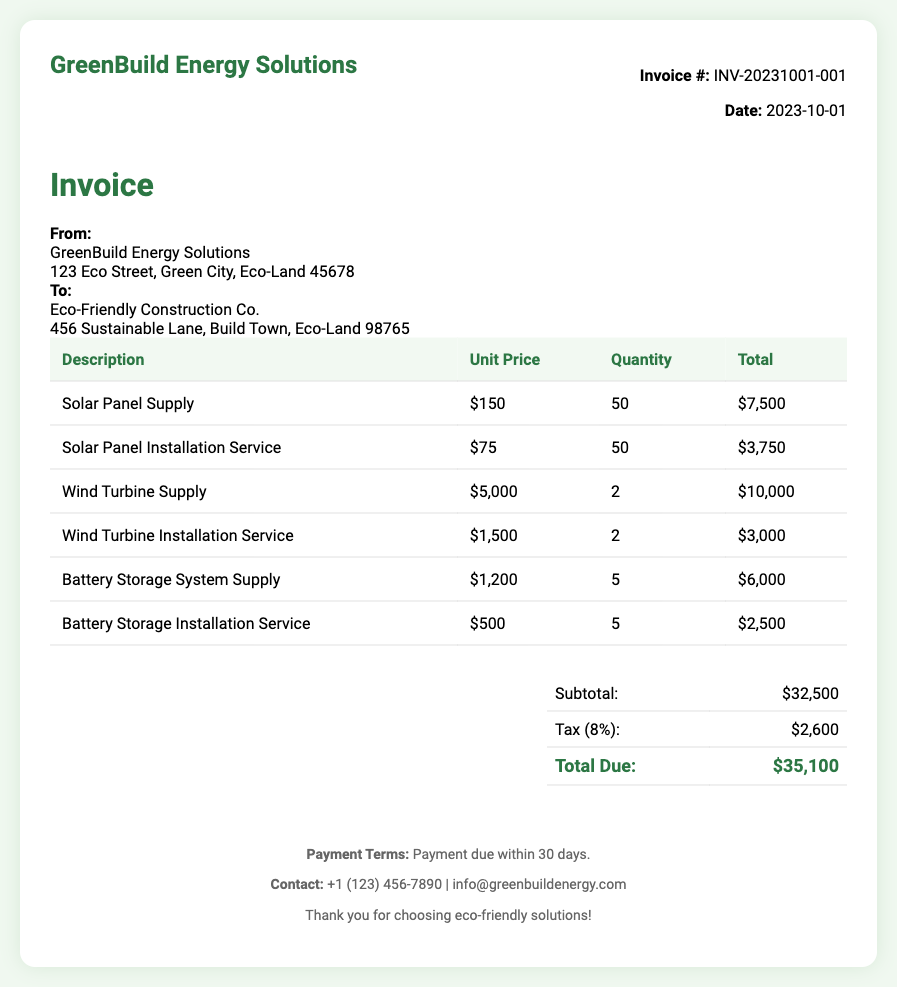What is the invoice number? The invoice number is specified in the document under invoice details.
Answer: INV-20231001-001 What is the date of the invoice? The date is provided clearly in the document.
Answer: 2023-10-01 Who is the recipient of the invoice? The recipient's name and address are mentioned in the "To:" section of the document.
Answer: Eco-Friendly Construction Co What is the unit price of a solar panel? The unit price is listed in the invoice table for solar panel supply.
Answer: $150 How many wind turbines were supplied? The quantity of wind turbines is noted in the invoice table under the wind turbine supply section.
Answer: 2 What is the subtotal amount before tax? The subtotal is listed directly in the summary section of the document.
Answer: $32,500 What is the tax percentage applied to the subtotal? The tax percentage is mentioned in the summary table of the invoice.
Answer: 8% What is the total amount due? The total due amount is clearly provided in the summary section.
Answer: $35,100 What is the contact number for GreenBuild Energy Solutions? The contact number is provided in the footer of the document.
Answer: +1 (123) 456-7890 